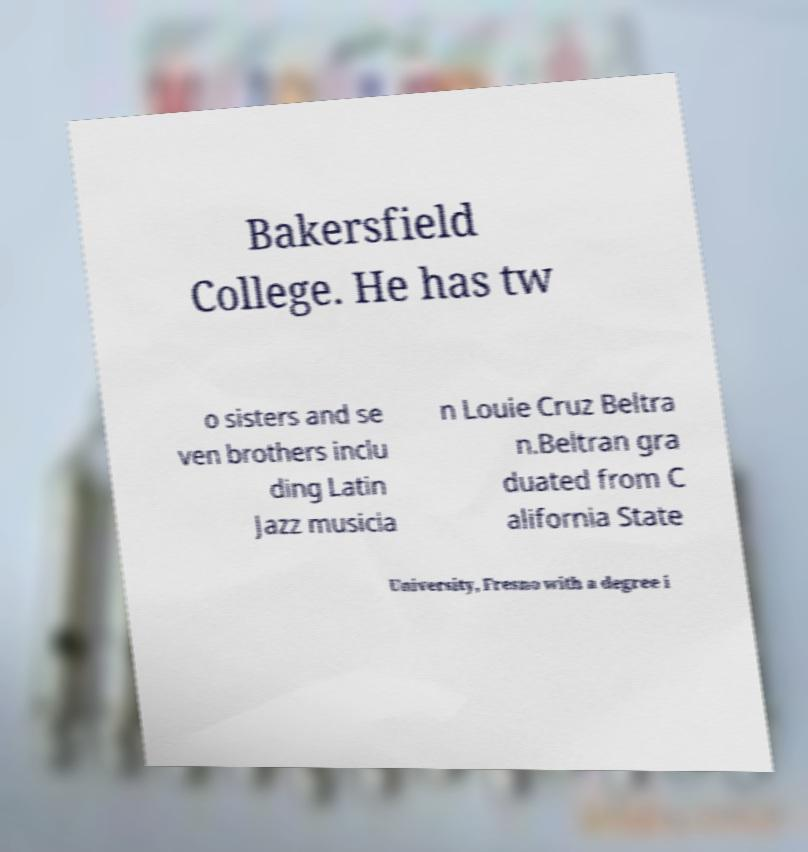What messages or text are displayed in this image? I need them in a readable, typed format. Bakersfield College. He has tw o sisters and se ven brothers inclu ding Latin Jazz musicia n Louie Cruz Beltra n.Beltran gra duated from C alifornia State University, Fresno with a degree i 